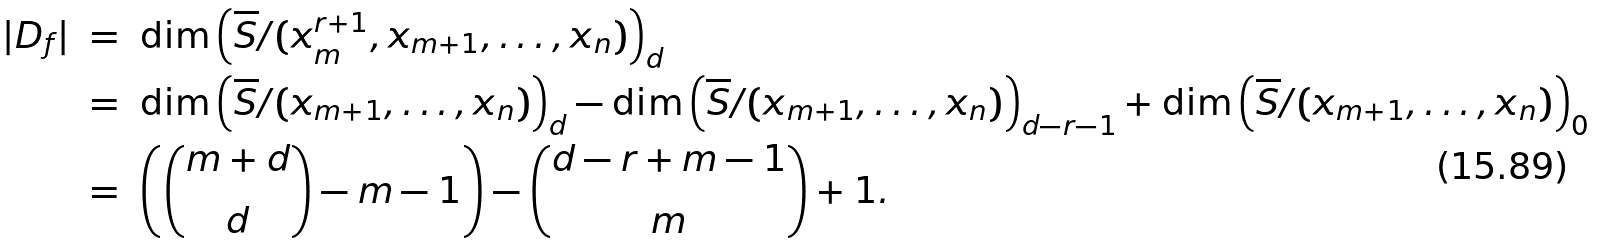<formula> <loc_0><loc_0><loc_500><loc_500>| D _ { f } | \ & = \ \dim \left ( \overline { S } / ( x _ { m } ^ { r + 1 } , x _ { m + 1 } , \dots , x _ { n } ) \right ) _ { d } \\ & = \ \dim \left ( \overline { S } / ( x _ { m + 1 } , \dots , x _ { n } ) \right ) _ { d } - \dim \left ( \overline { S } / ( x _ { m + 1 } , \dots , x _ { n } ) \right ) _ { d - r - 1 } + \dim \left ( \overline { S } / ( x _ { m + 1 } , \dots , x _ { n } ) \right ) _ { 0 } \\ & = \ \left ( \binom { m + d } { d } - m - 1 \right ) - \binom { d - r + m - 1 } { m } + 1 .</formula> 